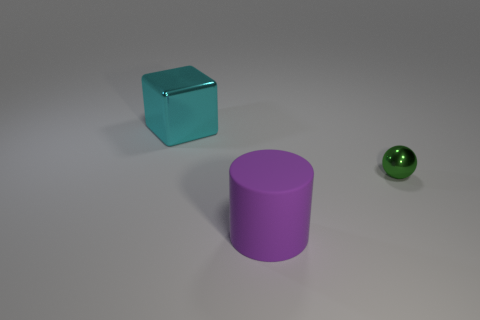What is the color of the large thing that is the same material as the tiny ball?
Provide a succinct answer. Cyan. There is a shiny object that is to the left of the metal sphere; is its size the same as the purple matte thing?
Your answer should be compact. Yes. What shape is the big thing that is in front of the object that is behind the metal thing that is in front of the cube?
Provide a short and direct response. Cylinder. Is the shape of the small shiny object the same as the purple rubber thing?
Make the answer very short. No. There is a object left of the big thing that is in front of the cyan block; what shape is it?
Offer a terse response. Cube. Are there any big purple rubber things?
Provide a short and direct response. Yes. How many tiny spheres are to the left of the metal thing that is on the right side of the thing that is left of the purple rubber cylinder?
Your answer should be very brief. 0. There is a large rubber object; does it have the same shape as the thing that is to the left of the rubber cylinder?
Your answer should be very brief. No. Are there more green things than blue balls?
Your answer should be compact. Yes. Is there anything else that is the same size as the green thing?
Provide a succinct answer. No. 